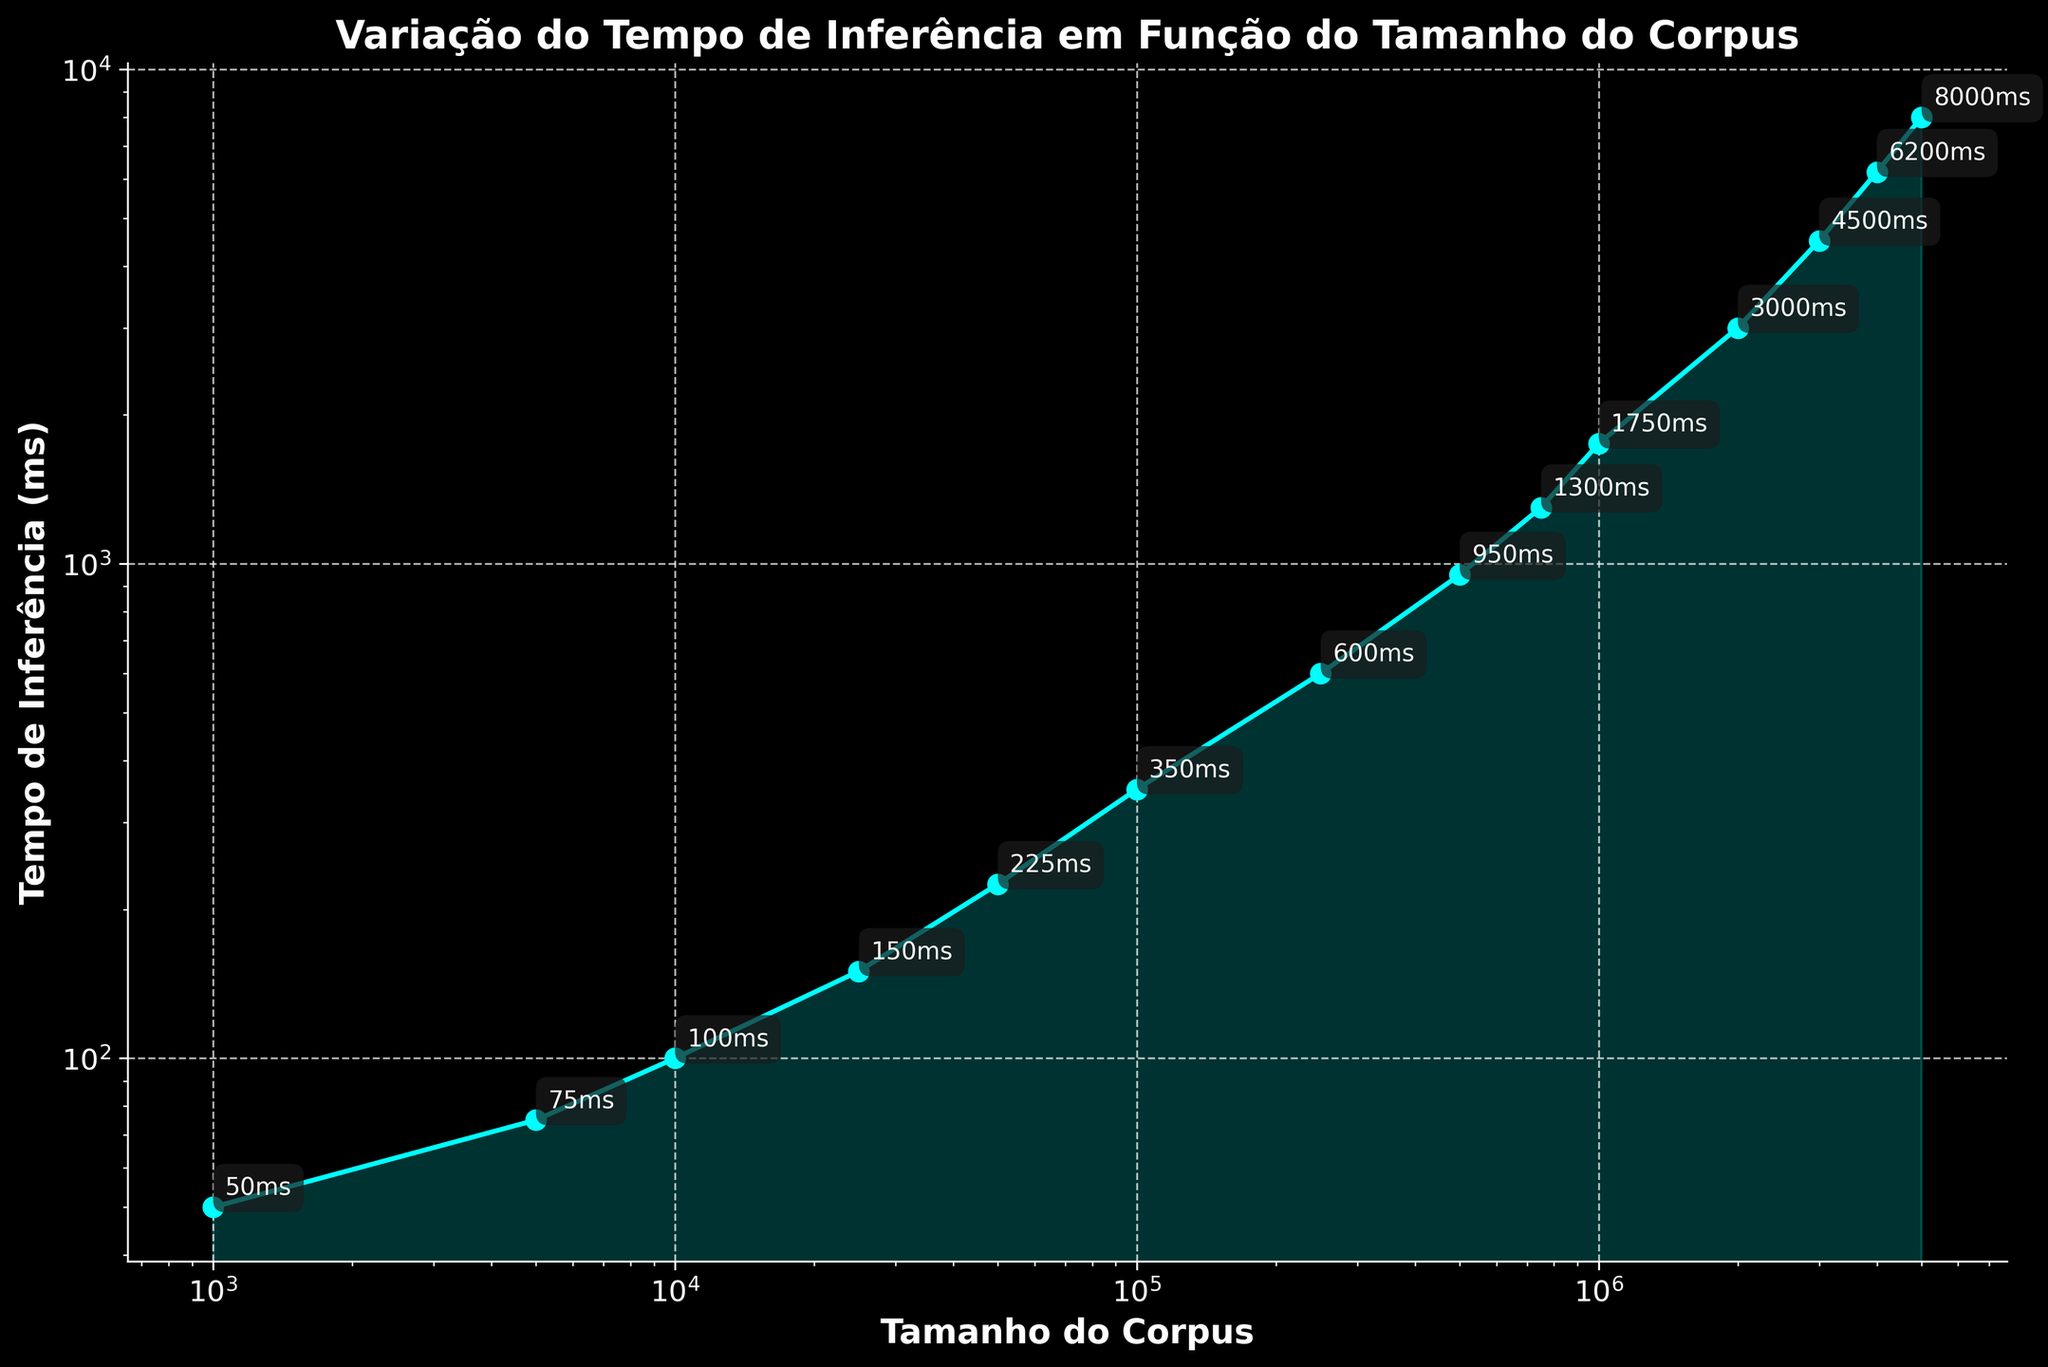what is the tempo de inferência for a corpus size of 10,000? The plot shows that for a corpus size of 10,000, the tempo de inferência is labeled directly on the point.
Answer: 100 ms How does the tempo de inferência change as the corpus size increases from 1,000 to 10,000? As we move from 1,000 to 10,000 on the x-axis, the tempo de inferência increases from 50 ms to 100 ms.
Answer: It doubles Between which two corpus sizes does the tempo de inferência see the largest increase? The plot shows the largest increase between 4,000,000 and 5,000,000 where the tempo de inferência goes from 6,200 ms to 8,000 ms.
Answer: 4,000,000 to 5,000,000 Is the relationship between corpus size and tempo de inferência linear? The plot uses a logarithmic scale on both axes, and the trend doesn't form a straight line, indicating a non-linear relationship.
Answer: No What is the largest tempo de inferência shown? Ask for the highest value labeled on the y-axis.
Answer: 8,000 ms What happens to the tempo de inferência when the corpus size increases tenfold from 100,000 to 1,000,000? Referencing the data points at 100,000 (350 ms) and 1,000,000 (1,750 ms), it's clear that the tempo de inferência does not increase tenfold but by a factor of 5.
Answer: Increases by 5 times Which corpus size corresponds to a tempo de inferência of approximately 225 ms? The plot shows this point at a corpus size of 50,000.
Answer: 50,000 What is the tempo de inferência for the smallest corpus size plotted? The point at the smallest corpus size, 1,000, indicates a tempo de inferência of 50 ms.
Answer: 50 ms Between which corpus sizes does the tempo de inferência stay below 1,000 ms? The tempo de inferência is below 1,000 ms from the smallest corpus size plotted (1,000) up to 500,000.
Answer: 1,000 to 500,000 What can you infer about the computational efficiency of the NLP models as the corpus size increases? The tempo de inferência increases at a progressively higher rate, implying that the models become less computationally efficient with larger corpus sizes.
Answer: Decreases with larger sizes 